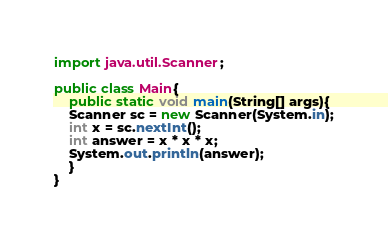Convert code to text. <code><loc_0><loc_0><loc_500><loc_500><_Java_>import java.util.Scanner;

public class Main{
    public static void main(String[] args){
	Scanner sc = new Scanner(System.in);
	int x = sc.nextInt();
	int answer = x * x * x;
	System.out.println(answer);
    }
}</code> 